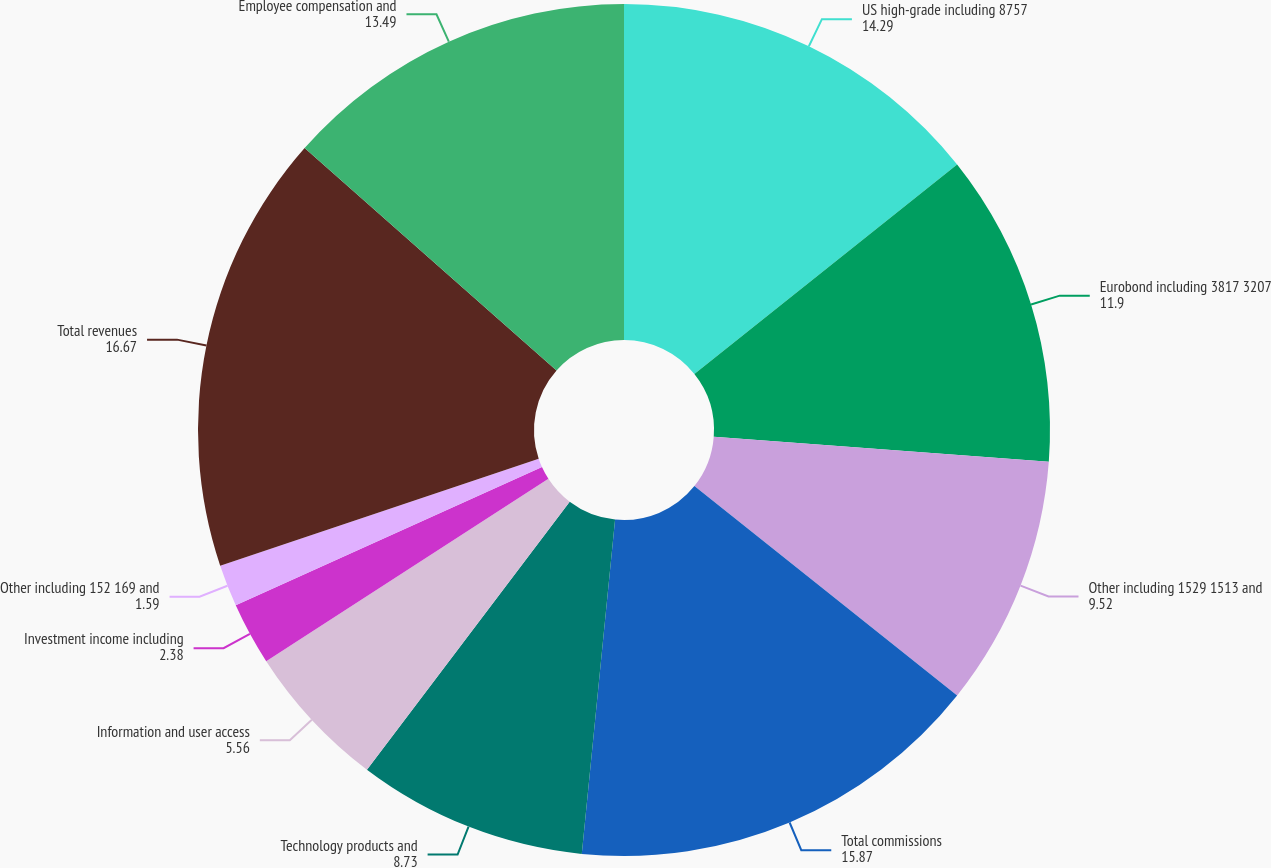<chart> <loc_0><loc_0><loc_500><loc_500><pie_chart><fcel>US high-grade including 8757<fcel>Eurobond including 3817 3207<fcel>Other including 1529 1513 and<fcel>Total commissions<fcel>Technology products and<fcel>Information and user access<fcel>Investment income including<fcel>Other including 152 169 and<fcel>Total revenues<fcel>Employee compensation and<nl><fcel>14.29%<fcel>11.9%<fcel>9.52%<fcel>15.87%<fcel>8.73%<fcel>5.56%<fcel>2.38%<fcel>1.59%<fcel>16.67%<fcel>13.49%<nl></chart> 